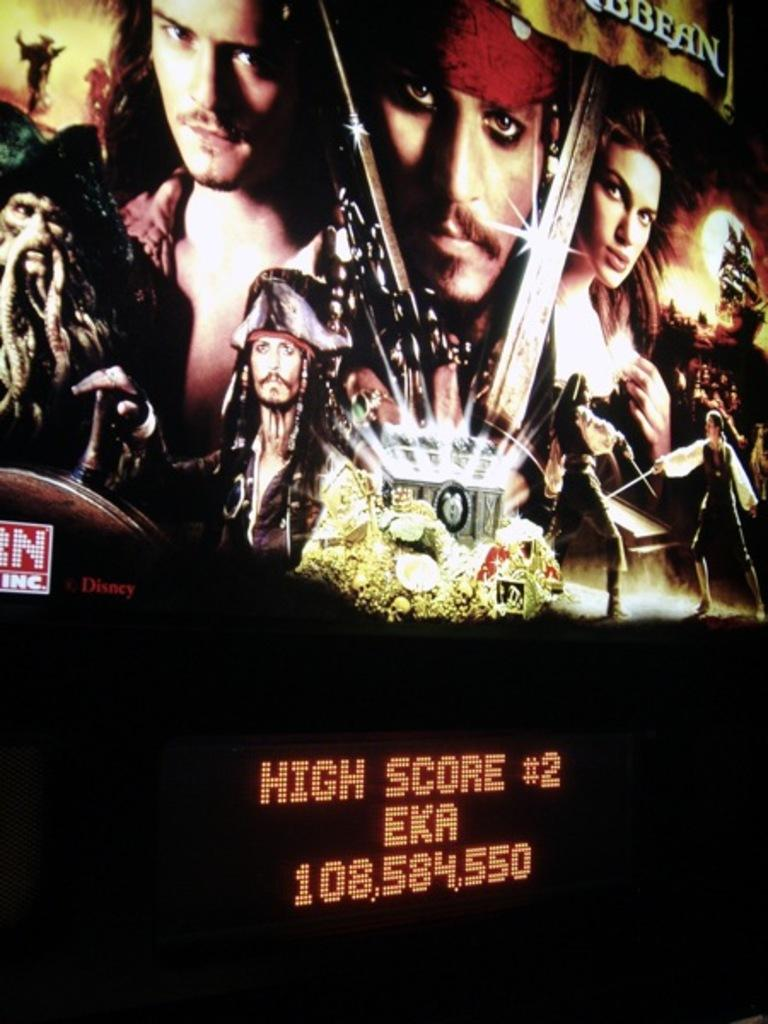<image>
Summarize the visual content of the image. Movie bilboard for the movie "The Pirates of Carribean". 